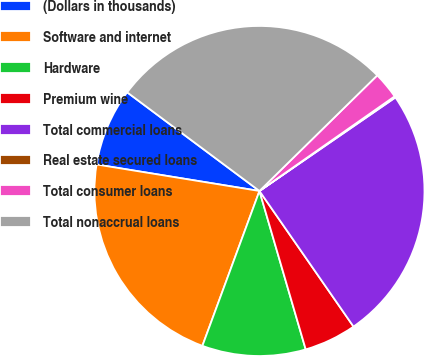Convert chart to OTSL. <chart><loc_0><loc_0><loc_500><loc_500><pie_chart><fcel>(Dollars in thousands)<fcel>Software and internet<fcel>Hardware<fcel>Premium wine<fcel>Total commercial loans<fcel>Real estate secured loans<fcel>Total consumer loans<fcel>Total nonaccrual loans<nl><fcel>7.63%<fcel>21.95%<fcel>10.14%<fcel>5.13%<fcel>24.94%<fcel>0.13%<fcel>2.63%<fcel>27.45%<nl></chart> 